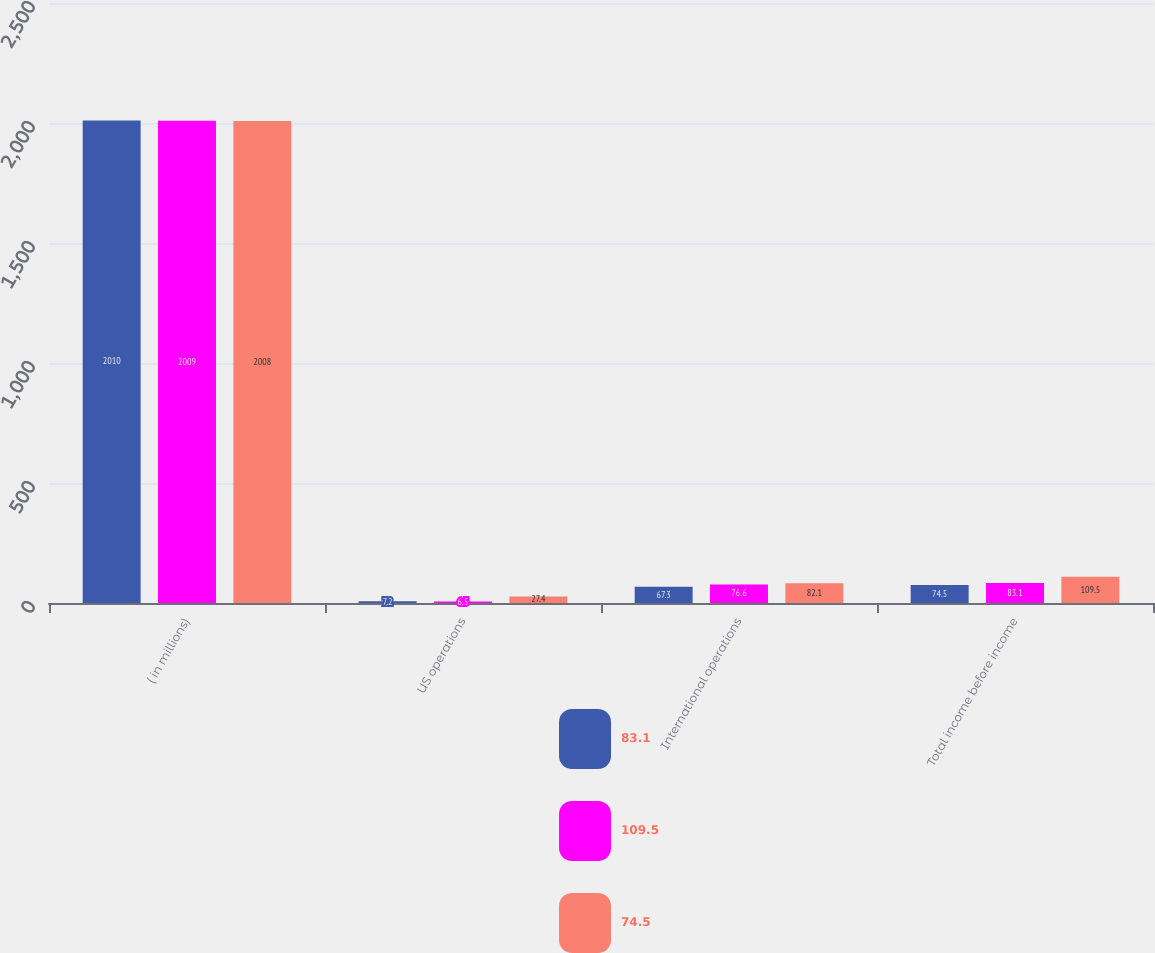Convert chart to OTSL. <chart><loc_0><loc_0><loc_500><loc_500><stacked_bar_chart><ecel><fcel>( in millions)<fcel>US operations<fcel>International operations<fcel>Total income before income<nl><fcel>83.1<fcel>2010<fcel>7.2<fcel>67.3<fcel>74.5<nl><fcel>109.5<fcel>2009<fcel>6.5<fcel>76.6<fcel>83.1<nl><fcel>74.5<fcel>2008<fcel>27.4<fcel>82.1<fcel>109.5<nl></chart> 